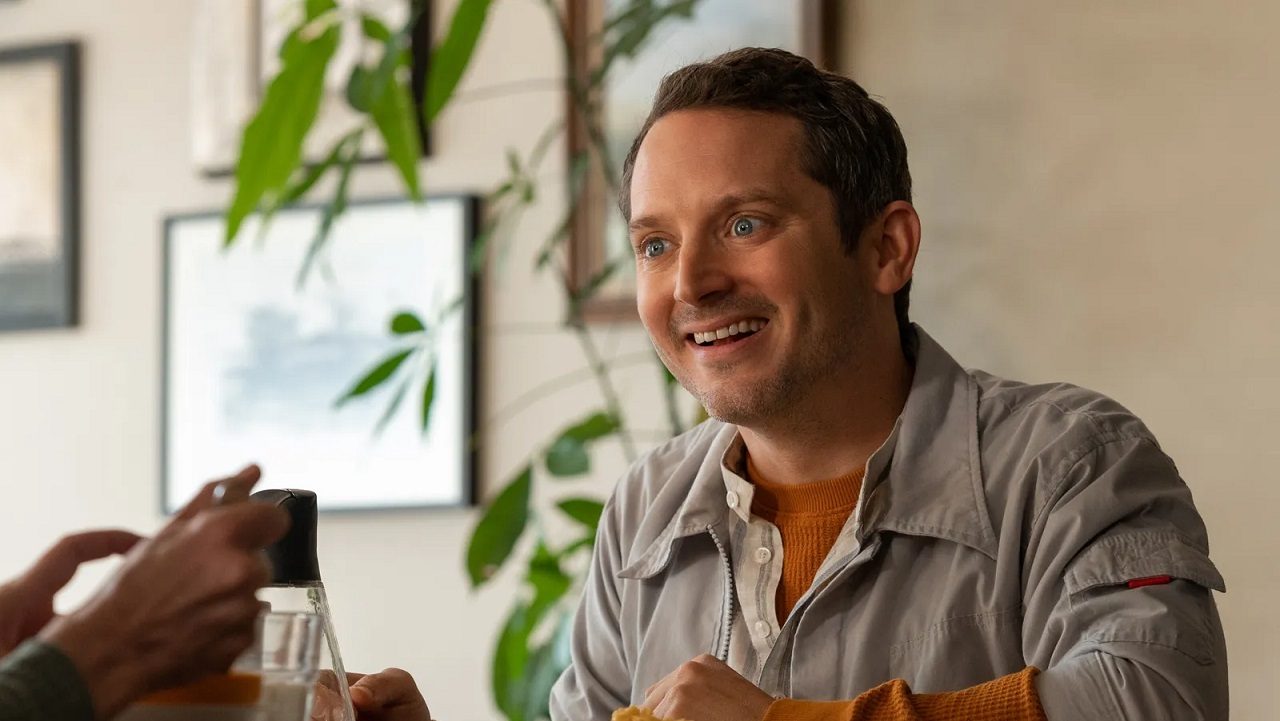Create a whimsical fairytale about the person in the image. Once upon a time, in a cozy village nestled between towering mountains and lush forests, there lived a kind-hearted innkeeper named Elion. Elion's inn was known far and wide for its warmth, delicious brews, and the enchanting tales he would tell by the fireside. One evening, as Elion was sharing a particularly magical story about a daring adventure with fairies and dragons, a mysterious traveler listened intently from the shadows. This traveler was actually a powerful wizard in disguise, searching for someone pure of heart to help save the magical realm from a terrible curse. Moved by Elion's kindness and bravery within his tales, the wizard revealed his true identity and asked for Elion’s help. Without hesitation, Elion agreed, embarking on a grand adventure filled with wonder, danger, and friendship. Along the journey, Elion’s genuine smile and unwavering optimism played a pivotal role in overcoming challenges and spreading light throughout the land. His inn became a legendary haven for all, where magic and happiness were forever abundant. 